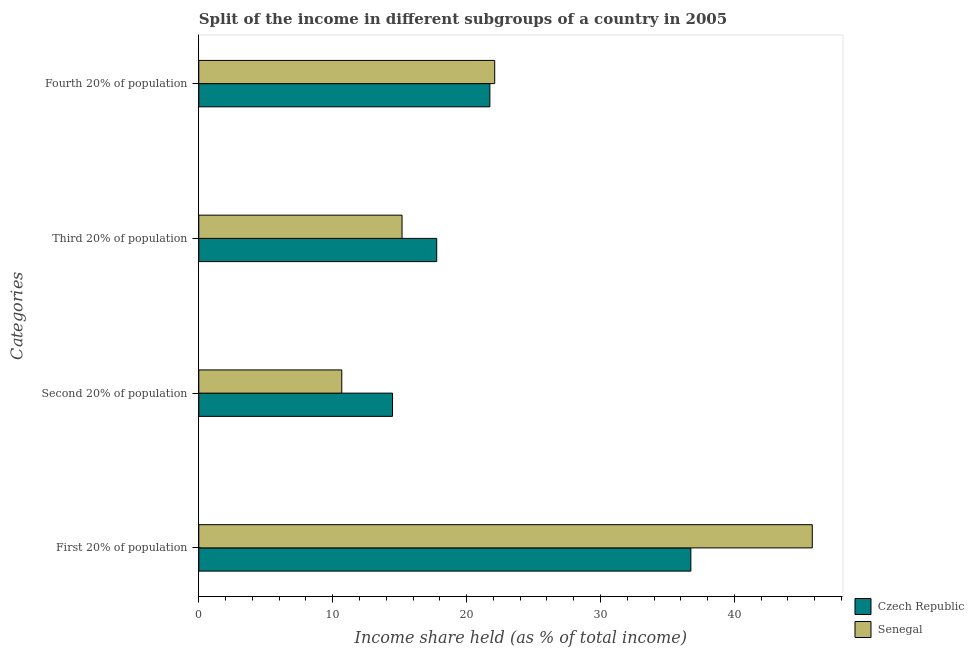How many different coloured bars are there?
Your answer should be very brief. 2. How many groups of bars are there?
Keep it short and to the point. 4. Are the number of bars per tick equal to the number of legend labels?
Offer a terse response. Yes. Are the number of bars on each tick of the Y-axis equal?
Offer a very short reply. Yes. What is the label of the 1st group of bars from the top?
Offer a very short reply. Fourth 20% of population. What is the share of the income held by third 20% of the population in Senegal?
Your answer should be compact. 15.18. Across all countries, what is the maximum share of the income held by second 20% of the population?
Make the answer very short. 14.47. Across all countries, what is the minimum share of the income held by third 20% of the population?
Ensure brevity in your answer.  15.18. In which country was the share of the income held by first 20% of the population maximum?
Offer a very short reply. Senegal. In which country was the share of the income held by first 20% of the population minimum?
Give a very brief answer. Czech Republic. What is the total share of the income held by first 20% of the population in the graph?
Keep it short and to the point. 82.57. What is the difference between the share of the income held by third 20% of the population in Senegal and that in Czech Republic?
Ensure brevity in your answer.  -2.59. What is the difference between the share of the income held by first 20% of the population in Senegal and the share of the income held by fourth 20% of the population in Czech Republic?
Offer a very short reply. 24.08. What is the average share of the income held by first 20% of the population per country?
Ensure brevity in your answer.  41.28. What is the difference between the share of the income held by third 20% of the population and share of the income held by fourth 20% of the population in Senegal?
Provide a succinct answer. -6.92. What is the ratio of the share of the income held by second 20% of the population in Senegal to that in Czech Republic?
Keep it short and to the point. 0.74. Is the share of the income held by third 20% of the population in Senegal less than that in Czech Republic?
Give a very brief answer. Yes. Is the difference between the share of the income held by second 20% of the population in Czech Republic and Senegal greater than the difference between the share of the income held by fourth 20% of the population in Czech Republic and Senegal?
Provide a short and direct response. Yes. What is the difference between the highest and the second highest share of the income held by first 20% of the population?
Give a very brief answer. 9.07. What is the difference between the highest and the lowest share of the income held by fourth 20% of the population?
Ensure brevity in your answer.  0.36. In how many countries, is the share of the income held by fourth 20% of the population greater than the average share of the income held by fourth 20% of the population taken over all countries?
Your answer should be compact. 1. Is the sum of the share of the income held by third 20% of the population in Czech Republic and Senegal greater than the maximum share of the income held by second 20% of the population across all countries?
Offer a terse response. Yes. What does the 2nd bar from the top in Fourth 20% of population represents?
Your answer should be compact. Czech Republic. What does the 2nd bar from the bottom in Third 20% of population represents?
Give a very brief answer. Senegal. Is it the case that in every country, the sum of the share of the income held by first 20% of the population and share of the income held by second 20% of the population is greater than the share of the income held by third 20% of the population?
Provide a short and direct response. Yes. How many bars are there?
Make the answer very short. 8. What is the difference between two consecutive major ticks on the X-axis?
Make the answer very short. 10. Does the graph contain grids?
Provide a short and direct response. No. Where does the legend appear in the graph?
Your response must be concise. Bottom right. What is the title of the graph?
Make the answer very short. Split of the income in different subgroups of a country in 2005. What is the label or title of the X-axis?
Provide a succinct answer. Income share held (as % of total income). What is the label or title of the Y-axis?
Your answer should be very brief. Categories. What is the Income share held (as % of total income) in Czech Republic in First 20% of population?
Keep it short and to the point. 36.75. What is the Income share held (as % of total income) of Senegal in First 20% of population?
Your answer should be very brief. 45.82. What is the Income share held (as % of total income) in Czech Republic in Second 20% of population?
Your response must be concise. 14.47. What is the Income share held (as % of total income) of Senegal in Second 20% of population?
Offer a terse response. 10.68. What is the Income share held (as % of total income) of Czech Republic in Third 20% of population?
Give a very brief answer. 17.77. What is the Income share held (as % of total income) in Senegal in Third 20% of population?
Make the answer very short. 15.18. What is the Income share held (as % of total income) in Czech Republic in Fourth 20% of population?
Your response must be concise. 21.74. What is the Income share held (as % of total income) of Senegal in Fourth 20% of population?
Your answer should be very brief. 22.1. Across all Categories, what is the maximum Income share held (as % of total income) in Czech Republic?
Make the answer very short. 36.75. Across all Categories, what is the maximum Income share held (as % of total income) of Senegal?
Provide a short and direct response. 45.82. Across all Categories, what is the minimum Income share held (as % of total income) in Czech Republic?
Offer a very short reply. 14.47. Across all Categories, what is the minimum Income share held (as % of total income) of Senegal?
Offer a terse response. 10.68. What is the total Income share held (as % of total income) of Czech Republic in the graph?
Provide a short and direct response. 90.73. What is the total Income share held (as % of total income) of Senegal in the graph?
Your answer should be compact. 93.78. What is the difference between the Income share held (as % of total income) of Czech Republic in First 20% of population and that in Second 20% of population?
Your response must be concise. 22.28. What is the difference between the Income share held (as % of total income) in Senegal in First 20% of population and that in Second 20% of population?
Ensure brevity in your answer.  35.14. What is the difference between the Income share held (as % of total income) of Czech Republic in First 20% of population and that in Third 20% of population?
Make the answer very short. 18.98. What is the difference between the Income share held (as % of total income) in Senegal in First 20% of population and that in Third 20% of population?
Keep it short and to the point. 30.64. What is the difference between the Income share held (as % of total income) in Czech Republic in First 20% of population and that in Fourth 20% of population?
Make the answer very short. 15.01. What is the difference between the Income share held (as % of total income) of Senegal in First 20% of population and that in Fourth 20% of population?
Make the answer very short. 23.72. What is the difference between the Income share held (as % of total income) in Czech Republic in Second 20% of population and that in Third 20% of population?
Your answer should be very brief. -3.3. What is the difference between the Income share held (as % of total income) in Czech Republic in Second 20% of population and that in Fourth 20% of population?
Provide a succinct answer. -7.27. What is the difference between the Income share held (as % of total income) in Senegal in Second 20% of population and that in Fourth 20% of population?
Provide a succinct answer. -11.42. What is the difference between the Income share held (as % of total income) of Czech Republic in Third 20% of population and that in Fourth 20% of population?
Offer a terse response. -3.97. What is the difference between the Income share held (as % of total income) in Senegal in Third 20% of population and that in Fourth 20% of population?
Ensure brevity in your answer.  -6.92. What is the difference between the Income share held (as % of total income) in Czech Republic in First 20% of population and the Income share held (as % of total income) in Senegal in Second 20% of population?
Your response must be concise. 26.07. What is the difference between the Income share held (as % of total income) of Czech Republic in First 20% of population and the Income share held (as % of total income) of Senegal in Third 20% of population?
Provide a succinct answer. 21.57. What is the difference between the Income share held (as % of total income) in Czech Republic in First 20% of population and the Income share held (as % of total income) in Senegal in Fourth 20% of population?
Offer a terse response. 14.65. What is the difference between the Income share held (as % of total income) in Czech Republic in Second 20% of population and the Income share held (as % of total income) in Senegal in Third 20% of population?
Make the answer very short. -0.71. What is the difference between the Income share held (as % of total income) of Czech Republic in Second 20% of population and the Income share held (as % of total income) of Senegal in Fourth 20% of population?
Provide a succinct answer. -7.63. What is the difference between the Income share held (as % of total income) of Czech Republic in Third 20% of population and the Income share held (as % of total income) of Senegal in Fourth 20% of population?
Keep it short and to the point. -4.33. What is the average Income share held (as % of total income) in Czech Republic per Categories?
Keep it short and to the point. 22.68. What is the average Income share held (as % of total income) of Senegal per Categories?
Provide a short and direct response. 23.45. What is the difference between the Income share held (as % of total income) of Czech Republic and Income share held (as % of total income) of Senegal in First 20% of population?
Provide a short and direct response. -9.07. What is the difference between the Income share held (as % of total income) of Czech Republic and Income share held (as % of total income) of Senegal in Second 20% of population?
Provide a succinct answer. 3.79. What is the difference between the Income share held (as % of total income) in Czech Republic and Income share held (as % of total income) in Senegal in Third 20% of population?
Your answer should be very brief. 2.59. What is the difference between the Income share held (as % of total income) in Czech Republic and Income share held (as % of total income) in Senegal in Fourth 20% of population?
Offer a very short reply. -0.36. What is the ratio of the Income share held (as % of total income) of Czech Republic in First 20% of population to that in Second 20% of population?
Offer a terse response. 2.54. What is the ratio of the Income share held (as % of total income) in Senegal in First 20% of population to that in Second 20% of population?
Your answer should be compact. 4.29. What is the ratio of the Income share held (as % of total income) of Czech Republic in First 20% of population to that in Third 20% of population?
Ensure brevity in your answer.  2.07. What is the ratio of the Income share held (as % of total income) in Senegal in First 20% of population to that in Third 20% of population?
Your answer should be compact. 3.02. What is the ratio of the Income share held (as % of total income) of Czech Republic in First 20% of population to that in Fourth 20% of population?
Make the answer very short. 1.69. What is the ratio of the Income share held (as % of total income) of Senegal in First 20% of population to that in Fourth 20% of population?
Give a very brief answer. 2.07. What is the ratio of the Income share held (as % of total income) in Czech Republic in Second 20% of population to that in Third 20% of population?
Give a very brief answer. 0.81. What is the ratio of the Income share held (as % of total income) of Senegal in Second 20% of population to that in Third 20% of population?
Your answer should be very brief. 0.7. What is the ratio of the Income share held (as % of total income) of Czech Republic in Second 20% of population to that in Fourth 20% of population?
Your answer should be very brief. 0.67. What is the ratio of the Income share held (as % of total income) in Senegal in Second 20% of population to that in Fourth 20% of population?
Ensure brevity in your answer.  0.48. What is the ratio of the Income share held (as % of total income) in Czech Republic in Third 20% of population to that in Fourth 20% of population?
Give a very brief answer. 0.82. What is the ratio of the Income share held (as % of total income) of Senegal in Third 20% of population to that in Fourth 20% of population?
Provide a succinct answer. 0.69. What is the difference between the highest and the second highest Income share held (as % of total income) in Czech Republic?
Your response must be concise. 15.01. What is the difference between the highest and the second highest Income share held (as % of total income) of Senegal?
Your response must be concise. 23.72. What is the difference between the highest and the lowest Income share held (as % of total income) in Czech Republic?
Your response must be concise. 22.28. What is the difference between the highest and the lowest Income share held (as % of total income) in Senegal?
Provide a short and direct response. 35.14. 